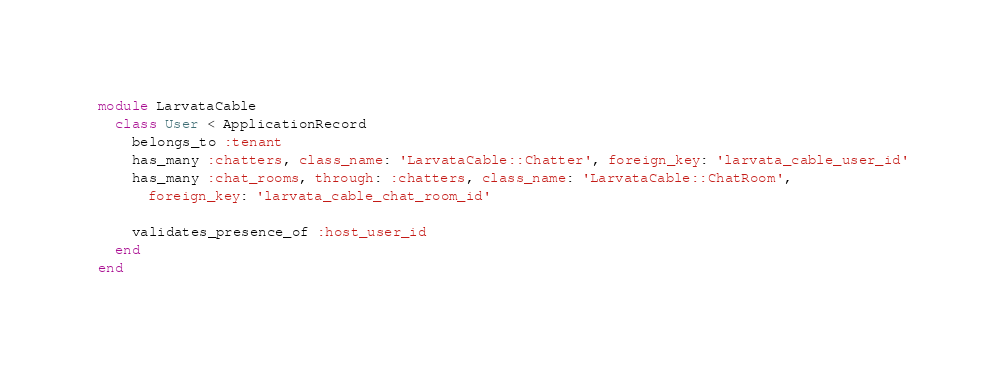Convert code to text. <code><loc_0><loc_0><loc_500><loc_500><_Ruby_>module LarvataCable
  class User < ApplicationRecord
    belongs_to :tenant
    has_many :chatters, class_name: 'LarvataCable::Chatter', foreign_key: 'larvata_cable_user_id'
    has_many :chat_rooms, through: :chatters, class_name: 'LarvataCable::ChatRoom',
      foreign_key: 'larvata_cable_chat_room_id'

    validates_presence_of :host_user_id
  end
end
</code> 